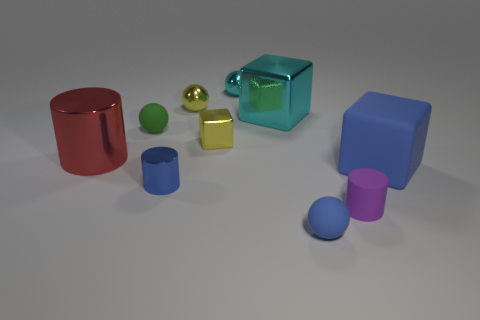Does the cyan metal ball have the same size as the rubber block?
Provide a succinct answer. No. What is the size of the yellow metal object that is behind the large cube on the left side of the purple matte cylinder?
Ensure brevity in your answer.  Small. There is a tiny matte object that is the same color as the big matte block; what shape is it?
Ensure brevity in your answer.  Sphere. What number of blocks are either big cyan metallic things or shiny things?
Ensure brevity in your answer.  2. There is a cyan ball; is it the same size as the rubber sphere in front of the green rubber thing?
Provide a succinct answer. Yes. Is the number of tiny things that are in front of the cyan metal sphere greater than the number of small cyan blocks?
Your response must be concise. Yes. The purple cylinder that is the same material as the blue ball is what size?
Make the answer very short. Small. Are there any metallic spheres of the same color as the tiny block?
Your answer should be very brief. Yes. How many objects are either green rubber objects or tiny metal things behind the cyan metal block?
Ensure brevity in your answer.  3. Are there more tiny cyan metal spheres than shiny things?
Your answer should be very brief. No. 